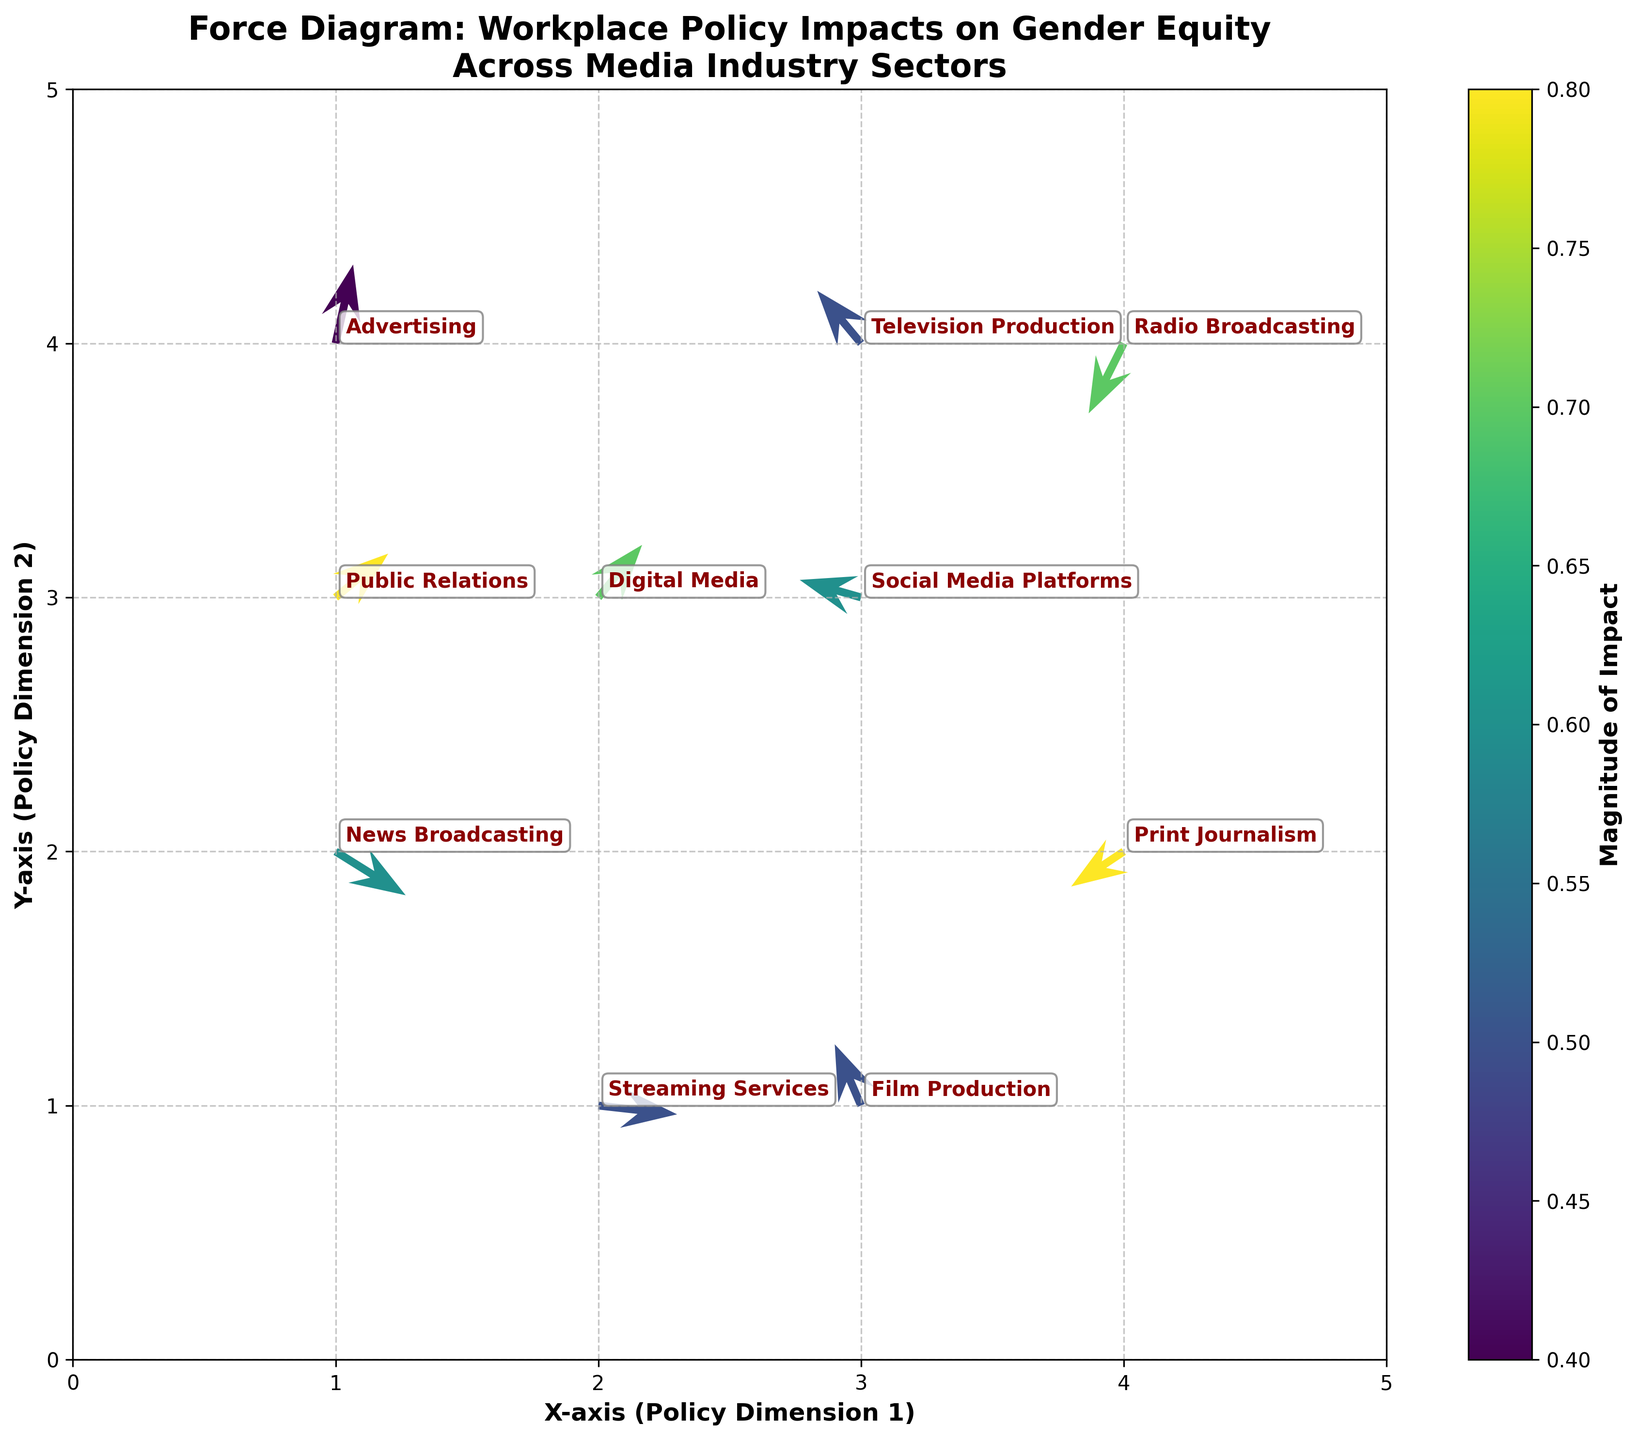What is the title of the plot? The title of the plot is displayed at the top and reads "Force Diagram: Workplace Policy Impacts on Gender Equity Across Media Industry Sectors".
Answer: Force Diagram: Workplace Policy Impacts on Gender Equity Across Media Industry Sectors What do the colors in the arrows represent? The color of the arrows represents the magnitude of the impact on gender equity, as indicated by the color bar on the right side of the plot. Darker colors usually indicate higher magnitudes.
Answer: The magnitude of the impact Which sector shows the highest impact magnitude? Analyzing the color of the arrows and reading the color bar, the "Print Journalism" sector has the highest impact magnitude with darker color coding.
Answer: Print Journalism What are the labels of the axes? The X-axis and the Y-axis labels are "X-axis (Policy Dimension 1)" and "Y-axis (Policy Dimension 2)" respectively, which are located near the bottom and left edges of the plot.
Answer: X-axis (Policy Dimension 1), Y-axis (Policy Dimension 2) How many sectors are included in the plot? Each annotation in the plot indicates a different sector. By counting these annotations, we find there are ten sectors displayed on the plot.
Answer: Ten sectors What are the coordinates of the arrow with the lowest impact magnitude? Finding the lightest-colored arrow and cross-referencing it with its coordinates, the "Advertising" sector at coordinates (1,4) shows the lowest impact magnitude.
Answer: (1,4) Which sector shows movement in the positive X direction and the negative Y direction? By observing the arrows pointing right (positive X) and down (negative Y), the "News Broadcasting" sector at (1,2) has this movement.
Answer: News Broadcasting Compare the magnitudes of impact on gender equity for "Public Relations" and "Social Media Platforms". Which is higher? Looking at the color intensity and referencing against the color bar, the "Public Relations" sector has a higher magnitude of impact than the "Social Media Platforms".
Answer: Public Relations Which sector shows movement purely in a positive X direction? By identifying arrows only pointing to the right with no up or down movement, the "Streaming Services" sector at (2,1) shows this movement.
Answer: Streaming Services What is the X and Y movement (u and v values) for the "Television Production" sector? The sector "Television Production" at coordinates (3,4) shows an X movement (u) of -0.5 and a Y movement (v) of 0.6, as annotated on the plot.
Answer: u: -0.5, v: 0.6 